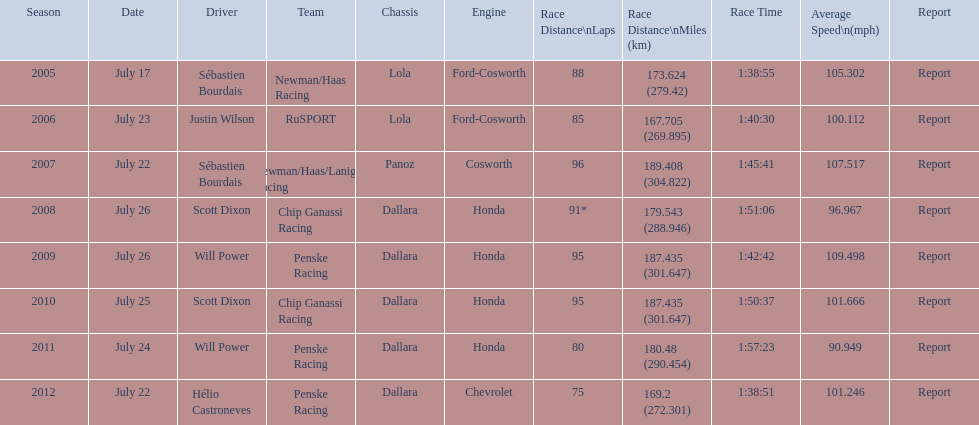What is the smallest quantity of laps done? 75. 